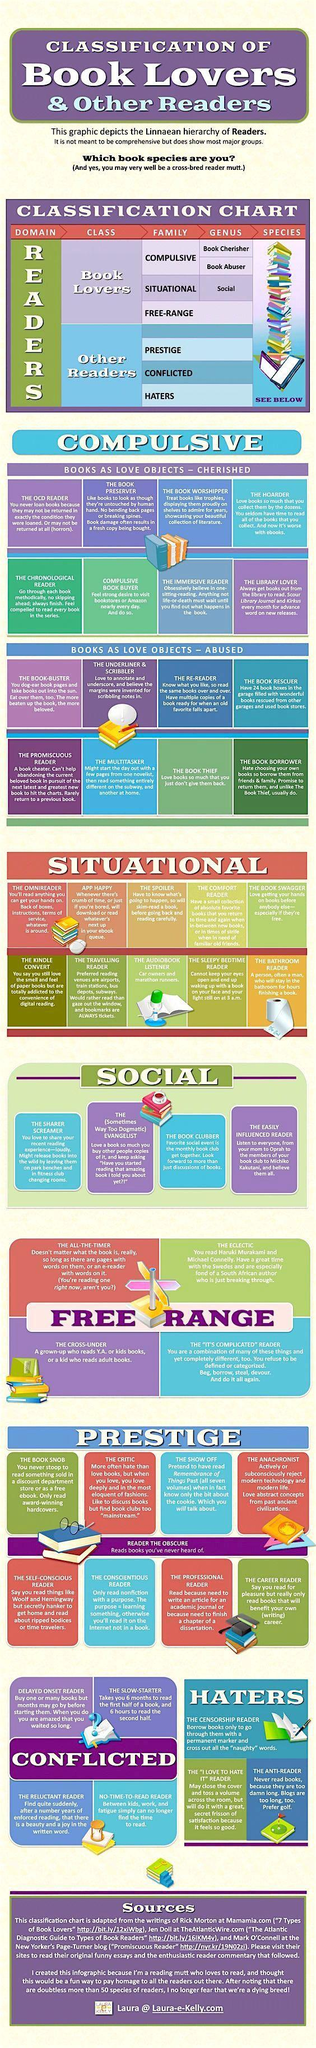Which situational reader is addicted to to digital reading?
Answer the question with a short phrase. The kindle convert How many types of haters are mentioned in the infographic? 3 Which compulsive book lover is most likely to replace a damaged book with a fresh copy? the book preserver What type of compulsive book lover never returns borrowed books? the book thief Which group of prestige readers read only books beneficial to their career? the career reader A reader who cannot find the time to read belongs to which family of readers? conflicted Which social reader is likely to leave books at park benches and changing rooms? The sharer screamer Who belongs to the genus 'Book Cherisher' - the book rescuer, the hoarder or the comfort reader? the hoarder Which is the third type of reader among the social readers? The book clubber The audio book listener belongs to which family of book lovers? situational 